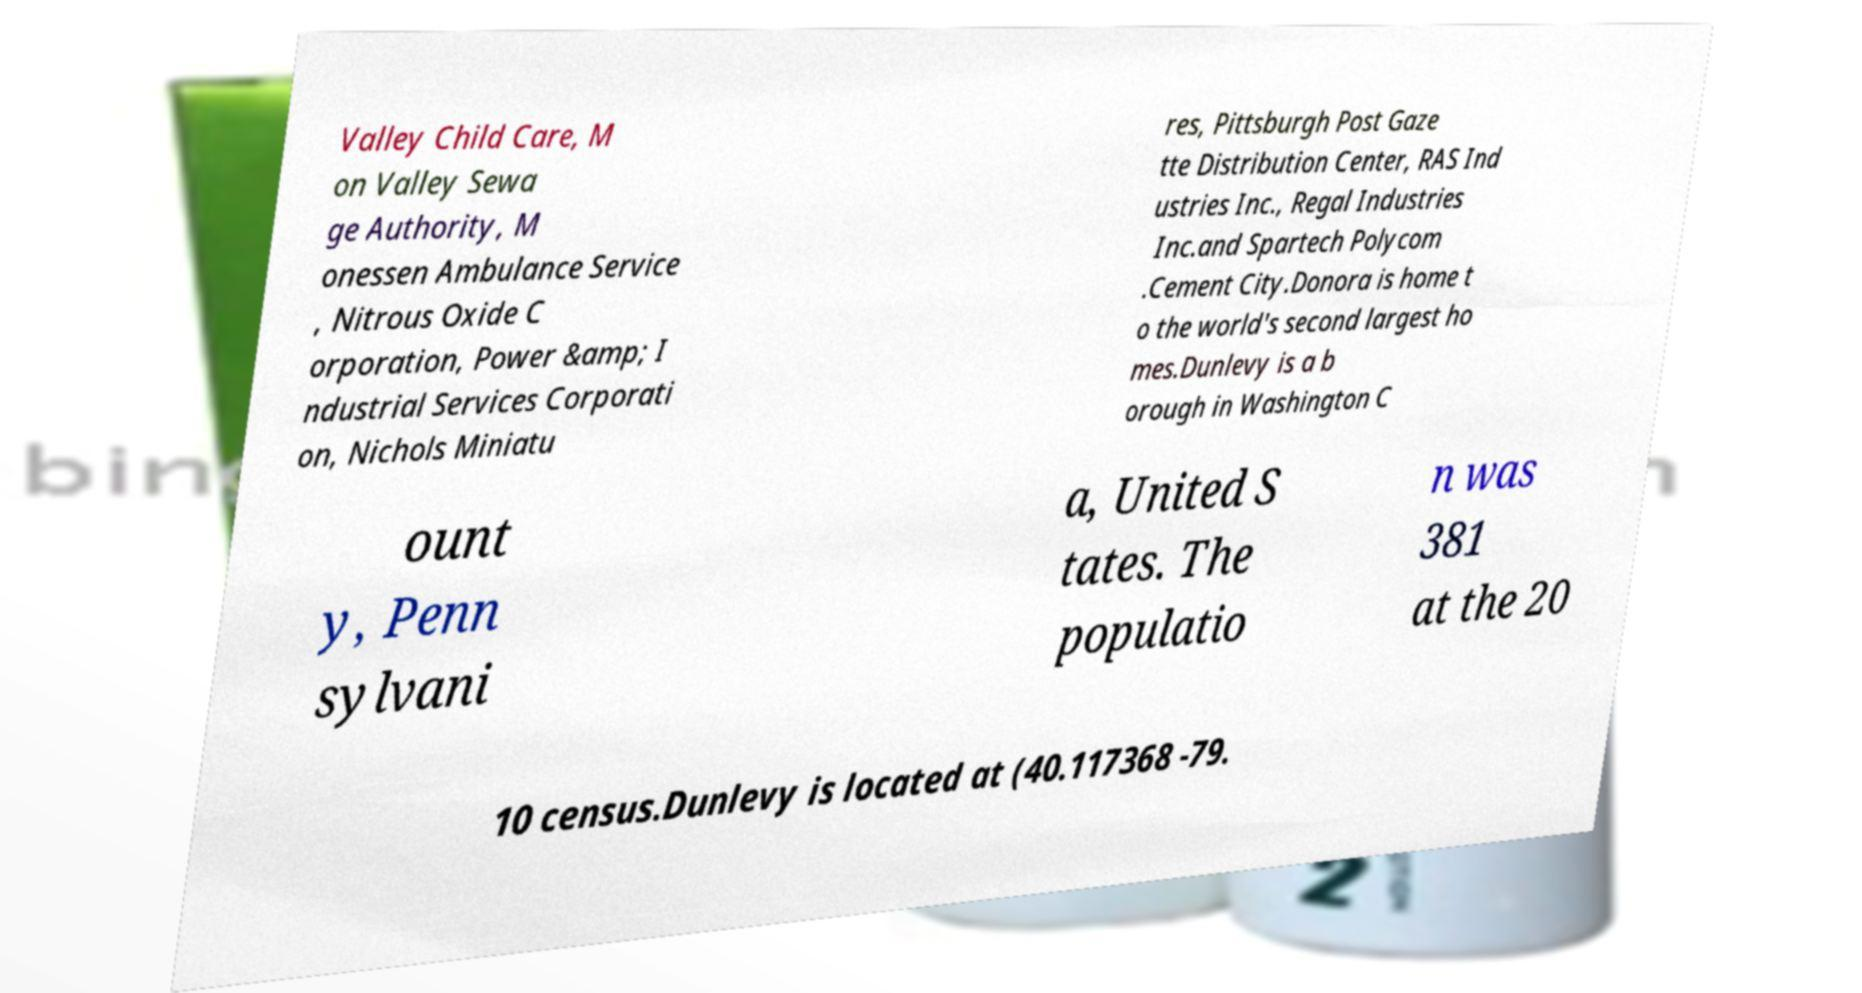Please identify and transcribe the text found in this image. Valley Child Care, M on Valley Sewa ge Authority, M onessen Ambulance Service , Nitrous Oxide C orporation, Power &amp; I ndustrial Services Corporati on, Nichols Miniatu res, Pittsburgh Post Gaze tte Distribution Center, RAS Ind ustries Inc., Regal Industries Inc.and Spartech Polycom .Cement City.Donora is home t o the world's second largest ho mes.Dunlevy is a b orough in Washington C ount y, Penn sylvani a, United S tates. The populatio n was 381 at the 20 10 census.Dunlevy is located at (40.117368 -79. 